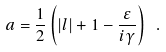Convert formula to latex. <formula><loc_0><loc_0><loc_500><loc_500>a = \frac { 1 } { 2 } \left ( | l | + 1 - \frac { \varepsilon } { i \gamma } \right ) \ .</formula> 